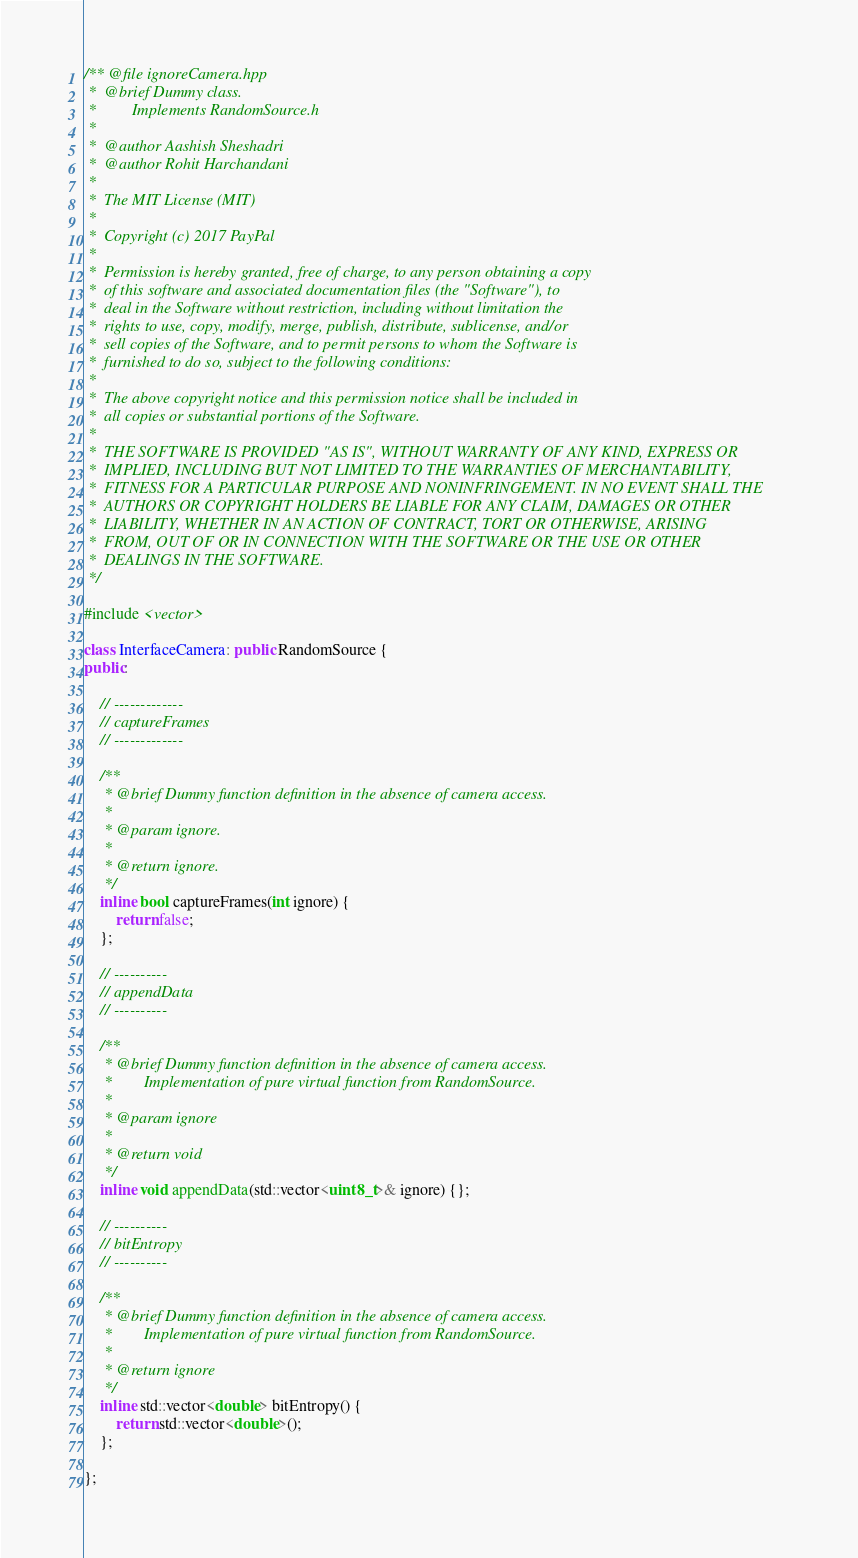<code> <loc_0><loc_0><loc_500><loc_500><_C++_>/** @file ignoreCamera.hpp
 *  @brief Dummy class.
 *         Implements RandomSource.h
 *
 *  @author Aashish Sheshadri
 *  @author Rohit Harchandani
 *
 *  The MIT License (MIT)
 *
 *  Copyright (c) 2017 PayPal
 *
 *  Permission is hereby granted, free of charge, to any person obtaining a copy
 *  of this software and associated documentation files (the "Software"), to
 *  deal in the Software without restriction, including without limitation the
 *  rights to use, copy, modify, merge, publish, distribute, sublicense, and/or
 *  sell copies of the Software, and to permit persons to whom the Software is
 *  furnished to do so, subject to the following conditions:
 *
 *  The above copyright notice and this permission notice shall be included in
 *  all copies or substantial portions of the Software.
 *
 *  THE SOFTWARE IS PROVIDED "AS IS", WITHOUT WARRANTY OF ANY KIND, EXPRESS OR
 *  IMPLIED, INCLUDING BUT NOT LIMITED TO THE WARRANTIES OF MERCHANTABILITY,
 *  FITNESS FOR A PARTICULAR PURPOSE AND NONINFRINGEMENT. IN NO EVENT SHALL THE
 *  AUTHORS OR COPYRIGHT HOLDERS BE LIABLE FOR ANY CLAIM, DAMAGES OR OTHER
 *  LIABILITY, WHETHER IN AN ACTION OF CONTRACT, TORT OR OTHERWISE, ARISING
 *  FROM, OUT OF OR IN CONNECTION WITH THE SOFTWARE OR THE USE OR OTHER
 *  DEALINGS IN THE SOFTWARE.
 */

#include <vector>

class InterfaceCamera: public RandomSource {
public:

    // -------------
    // captureFrames
    // -------------

    /**
     * @brief Dummy function definition in the absence of camera access.
     *
     * @param ignore.
     *
     * @return ignore.
     */
    inline bool captureFrames(int ignore) {
        return false;
    };

    // ----------
    // appendData
    // ----------

    /**
     * @brief Dummy function definition in the absence of camera access.
     *        Implementation of pure virtual function from RandomSource.
     *
     * @param ignore
     *
     * @return void
     */
    inline void appendData(std::vector<uint8_t>& ignore) {};

    // ----------
    // bitEntropy
    // ----------

    /**
     * @brief Dummy function definition in the absence of camera access.
     *        Implementation of pure virtual function from RandomSource.
     *
     * @return ignore
     */
    inline std::vector<double> bitEntropy() {
        return std::vector<double>();
    };

};
</code> 